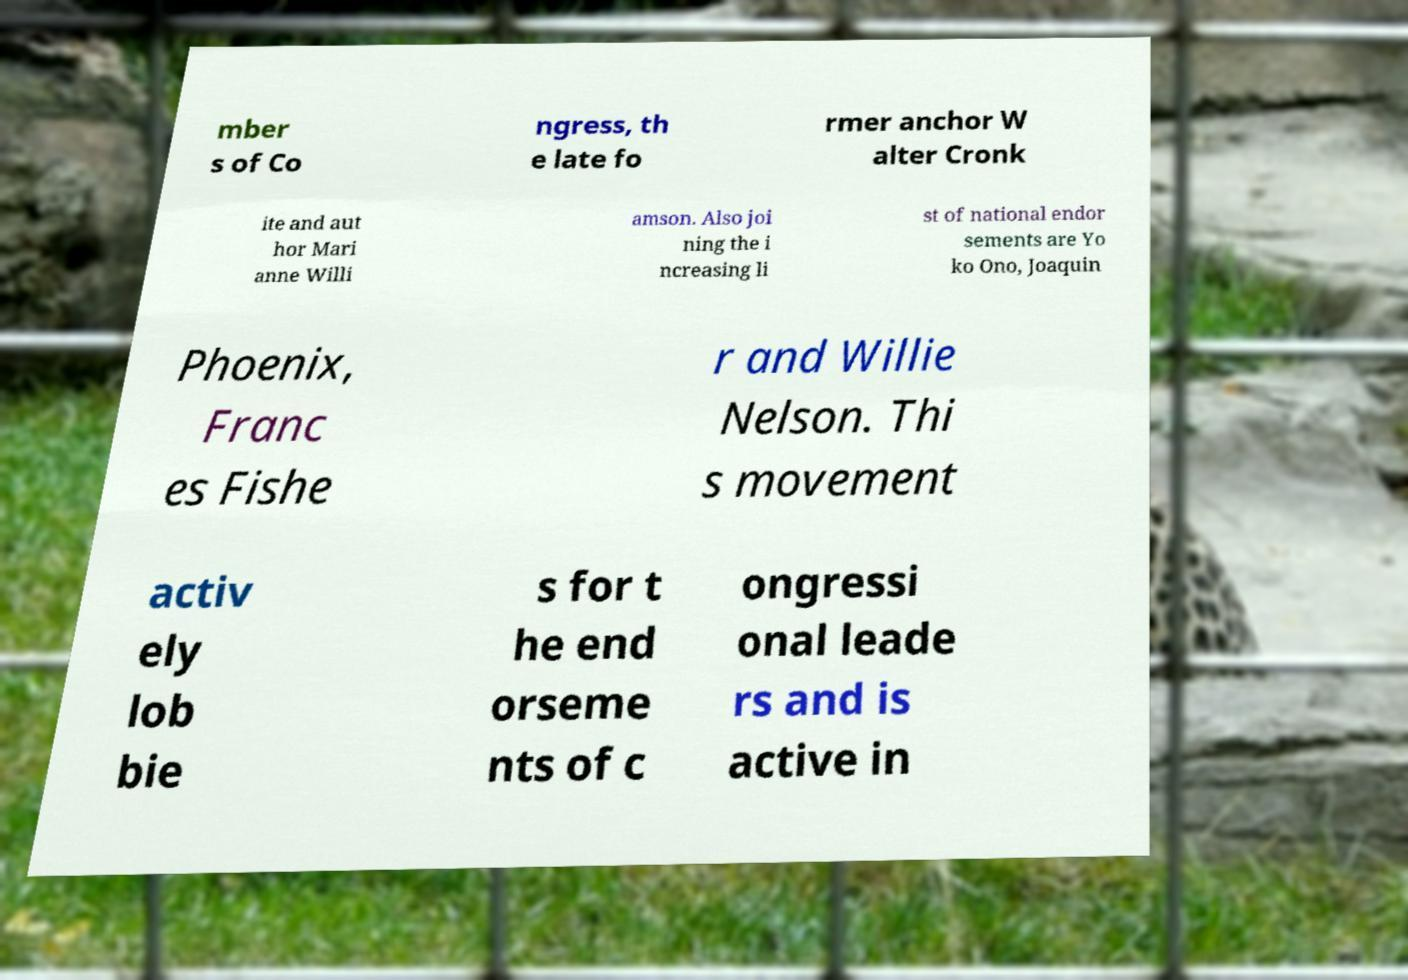Please identify and transcribe the text found in this image. mber s of Co ngress, th e late fo rmer anchor W alter Cronk ite and aut hor Mari anne Willi amson. Also joi ning the i ncreasing li st of national endor sements are Yo ko Ono, Joaquin Phoenix, Franc es Fishe r and Willie Nelson. Thi s movement activ ely lob bie s for t he end orseme nts of c ongressi onal leade rs and is active in 